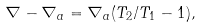<formula> <loc_0><loc_0><loc_500><loc_500>\nabla - \nabla _ { a } = \nabla _ { a } ( T _ { 2 } / T _ { 1 } - 1 ) ,</formula> 